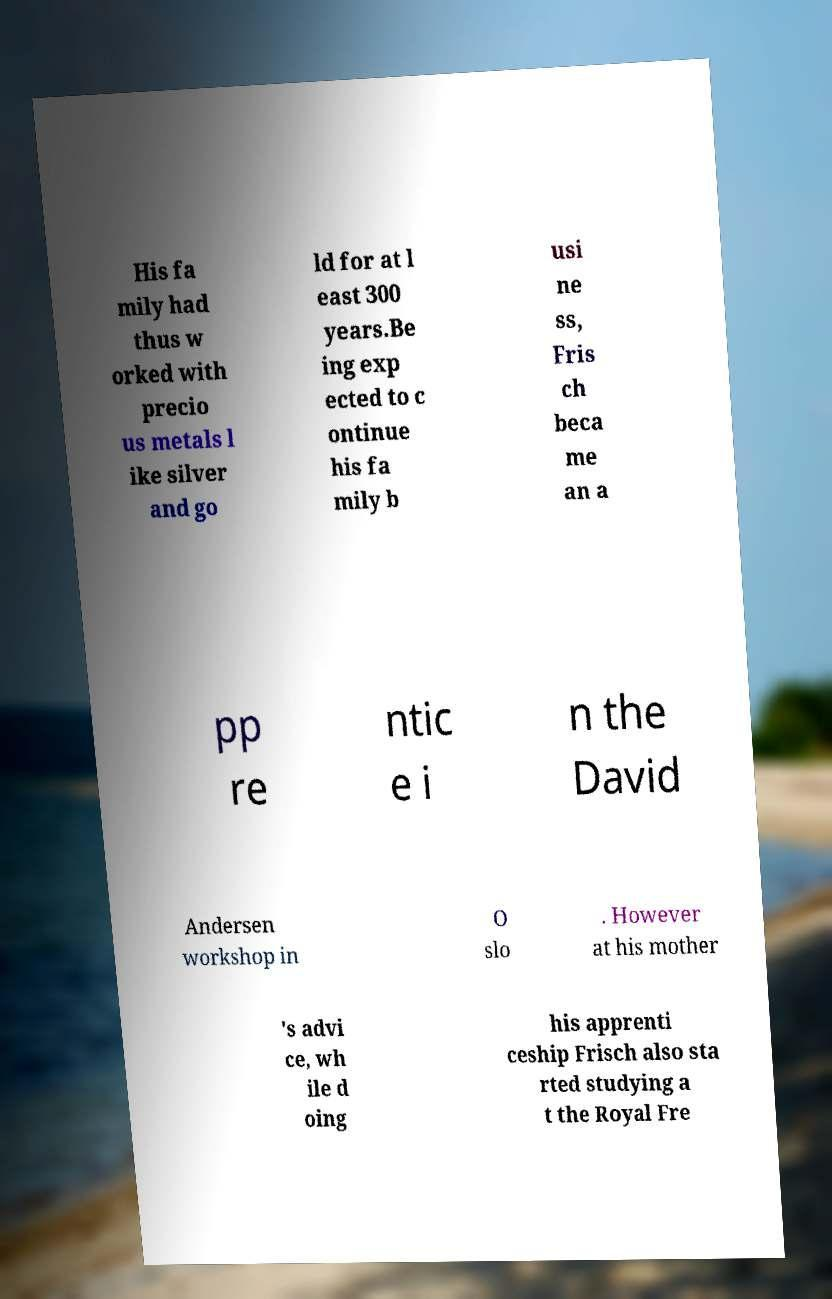Could you assist in decoding the text presented in this image and type it out clearly? His fa mily had thus w orked with precio us metals l ike silver and go ld for at l east 300 years.Be ing exp ected to c ontinue his fa mily b usi ne ss, Fris ch beca me an a pp re ntic e i n the David Andersen workshop in O slo . However at his mother 's advi ce, wh ile d oing his apprenti ceship Frisch also sta rted studying a t the Royal Fre 